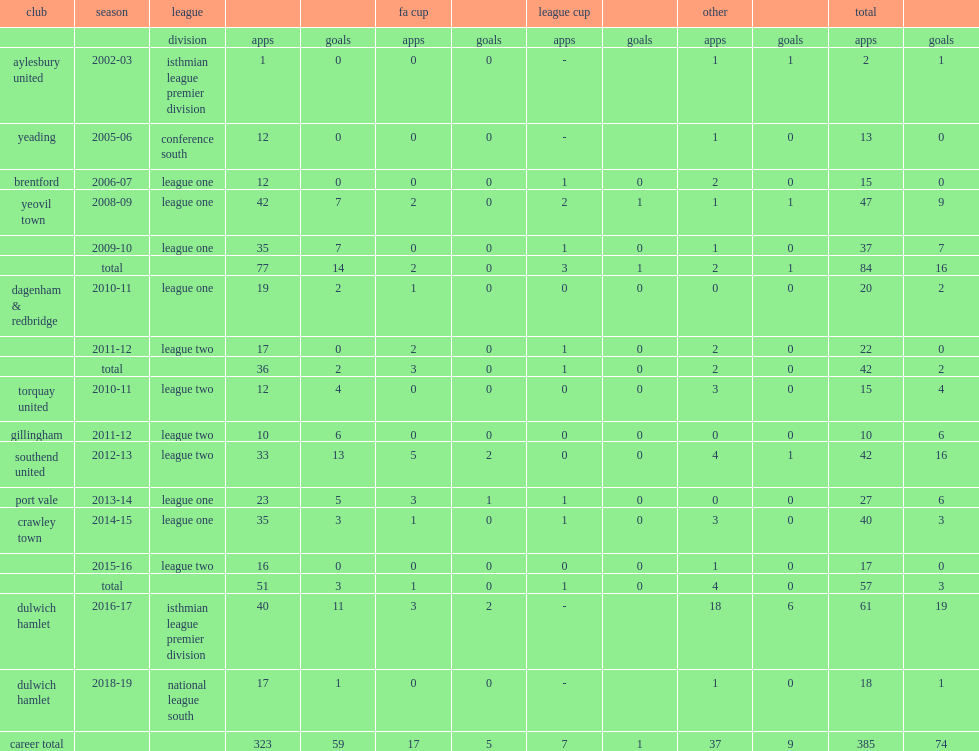Would you be able to parse every entry in this table? {'header': ['club', 'season', 'league', '', '', 'fa cup', '', 'league cup', '', 'other', '', 'total', ''], 'rows': [['', '', 'division', 'apps', 'goals', 'apps', 'goals', 'apps', 'goals', 'apps', 'goals', 'apps', 'goals'], ['aylesbury united', '2002-03', 'isthmian league premier division', '1', '0', '0', '0', '-', '', '1', '1', '2', '1'], ['yeading', '2005-06', 'conference south', '12', '0', '0', '0', '-', '', '1', '0', '13', '0'], ['brentford', '2006-07', 'league one', '12', '0', '0', '0', '1', '0', '2', '0', '15', '0'], ['yeovil town', '2008-09', 'league one', '42', '7', '2', '0', '2', '1', '1', '1', '47', '9'], ['', '2009-10', 'league one', '35', '7', '0', '0', '1', '0', '1', '0', '37', '7'], ['', 'total', '', '77', '14', '2', '0', '3', '1', '2', '1', '84', '16'], ['dagenham & redbridge', '2010-11', 'league one', '19', '2', '1', '0', '0', '0', '0', '0', '20', '2'], ['', '2011-12', 'league two', '17', '0', '2', '0', '1', '0', '2', '0', '22', '0'], ['', 'total', '', '36', '2', '3', '0', '1', '0', '2', '0', '42', '2'], ['torquay united', '2010-11', 'league two', '12', '4', '0', '0', '0', '0', '3', '0', '15', '4'], ['gillingham', '2011-12', 'league two', '10', '6', '0', '0', '0', '0', '0', '0', '10', '6'], ['southend united', '2012-13', 'league two', '33', '13', '5', '2', '0', '0', '4', '1', '42', '16'], ['port vale', '2013-14', 'league one', '23', '5', '3', '1', '1', '0', '0', '0', '27', '6'], ['crawley town', '2014-15', 'league one', '35', '3', '1', '0', '1', '0', '3', '0', '40', '3'], ['', '2015-16', 'league two', '16', '0', '0', '0', '0', '0', '1', '0', '17', '0'], ['', 'total', '', '51', '3', '1', '0', '1', '0', '4', '0', '57', '3'], ['dulwich hamlet', '2016-17', 'isthmian league premier division', '40', '11', '3', '2', '-', '', '18', '6', '61', '19'], ['dulwich hamlet', '2018-19', 'national league south', '17', '1', '0', '0', '-', '', '1', '0', '18', '1'], ['career total', '', '', '323', '59', '17', '5', '7', '1', '37', '9', '385', '74']]} Which club did gavin tomlin play for in 2005-06? Yeading. 